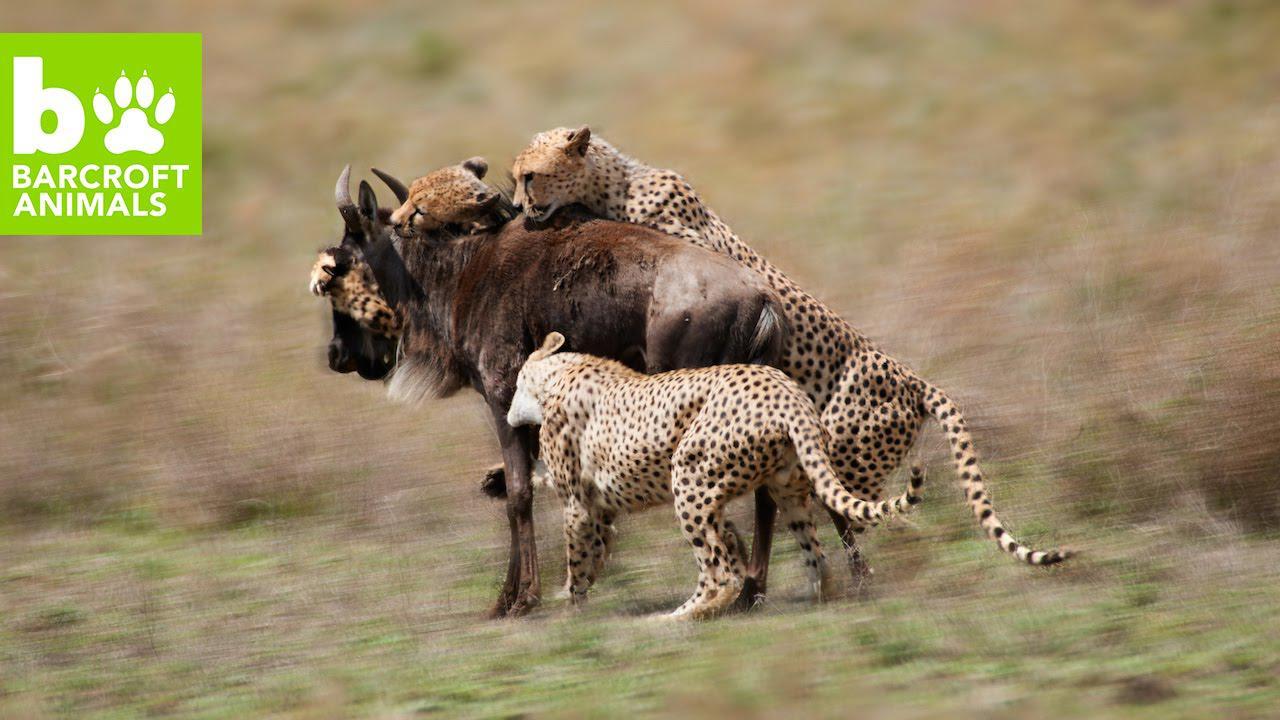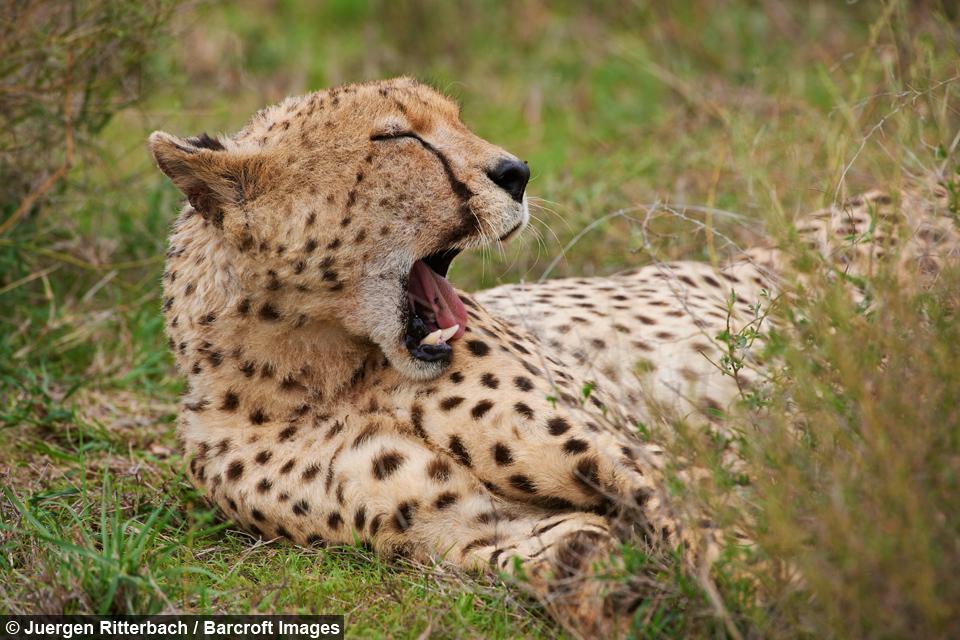The first image is the image on the left, the second image is the image on the right. For the images shown, is this caption "Left image shows spotted wild cats attacking an upright hooved animal." true? Answer yes or no. Yes. The first image is the image on the left, the second image is the image on the right. For the images shown, is this caption "There are no more than four cheetahs." true? Answer yes or no. Yes. 